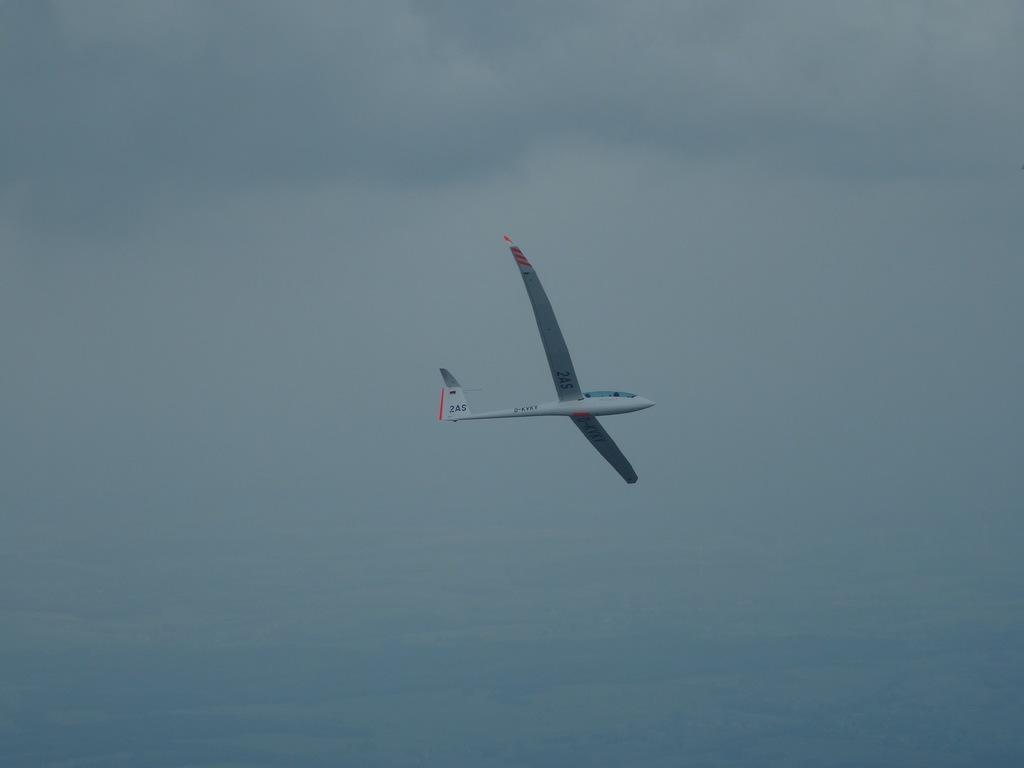Describe this image in one or two sentences. In the middle of this image, there is an aircraft flying in the air. In the background, there are clouds in the sky. 